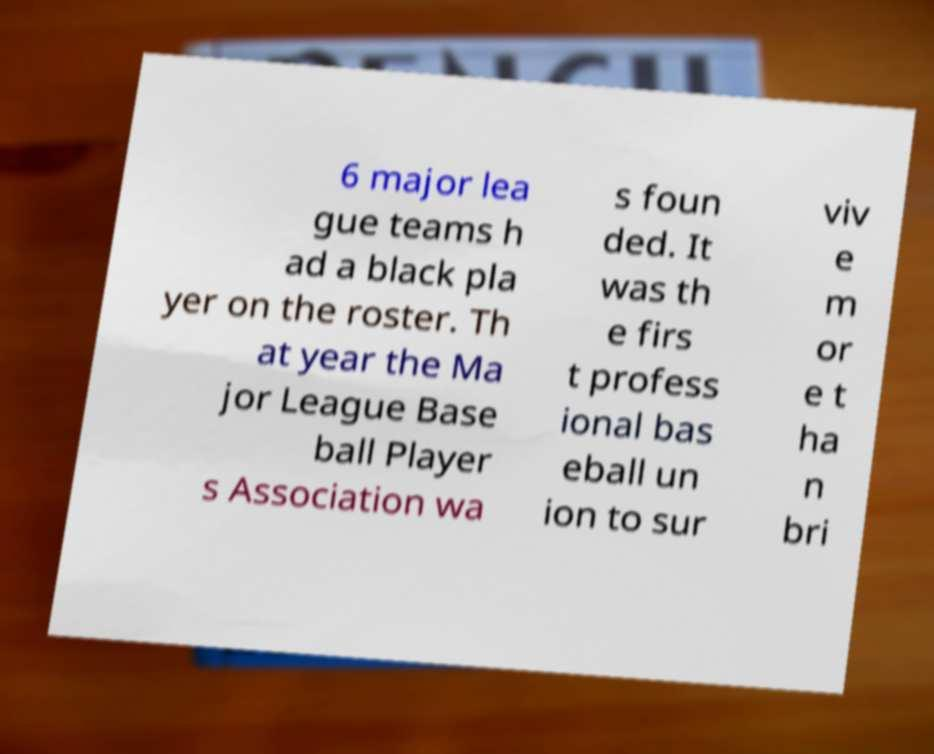Can you read and provide the text displayed in the image?This photo seems to have some interesting text. Can you extract and type it out for me? 6 major lea gue teams h ad a black pla yer on the roster. Th at year the Ma jor League Base ball Player s Association wa s foun ded. It was th e firs t profess ional bas eball un ion to sur viv e m or e t ha n bri 